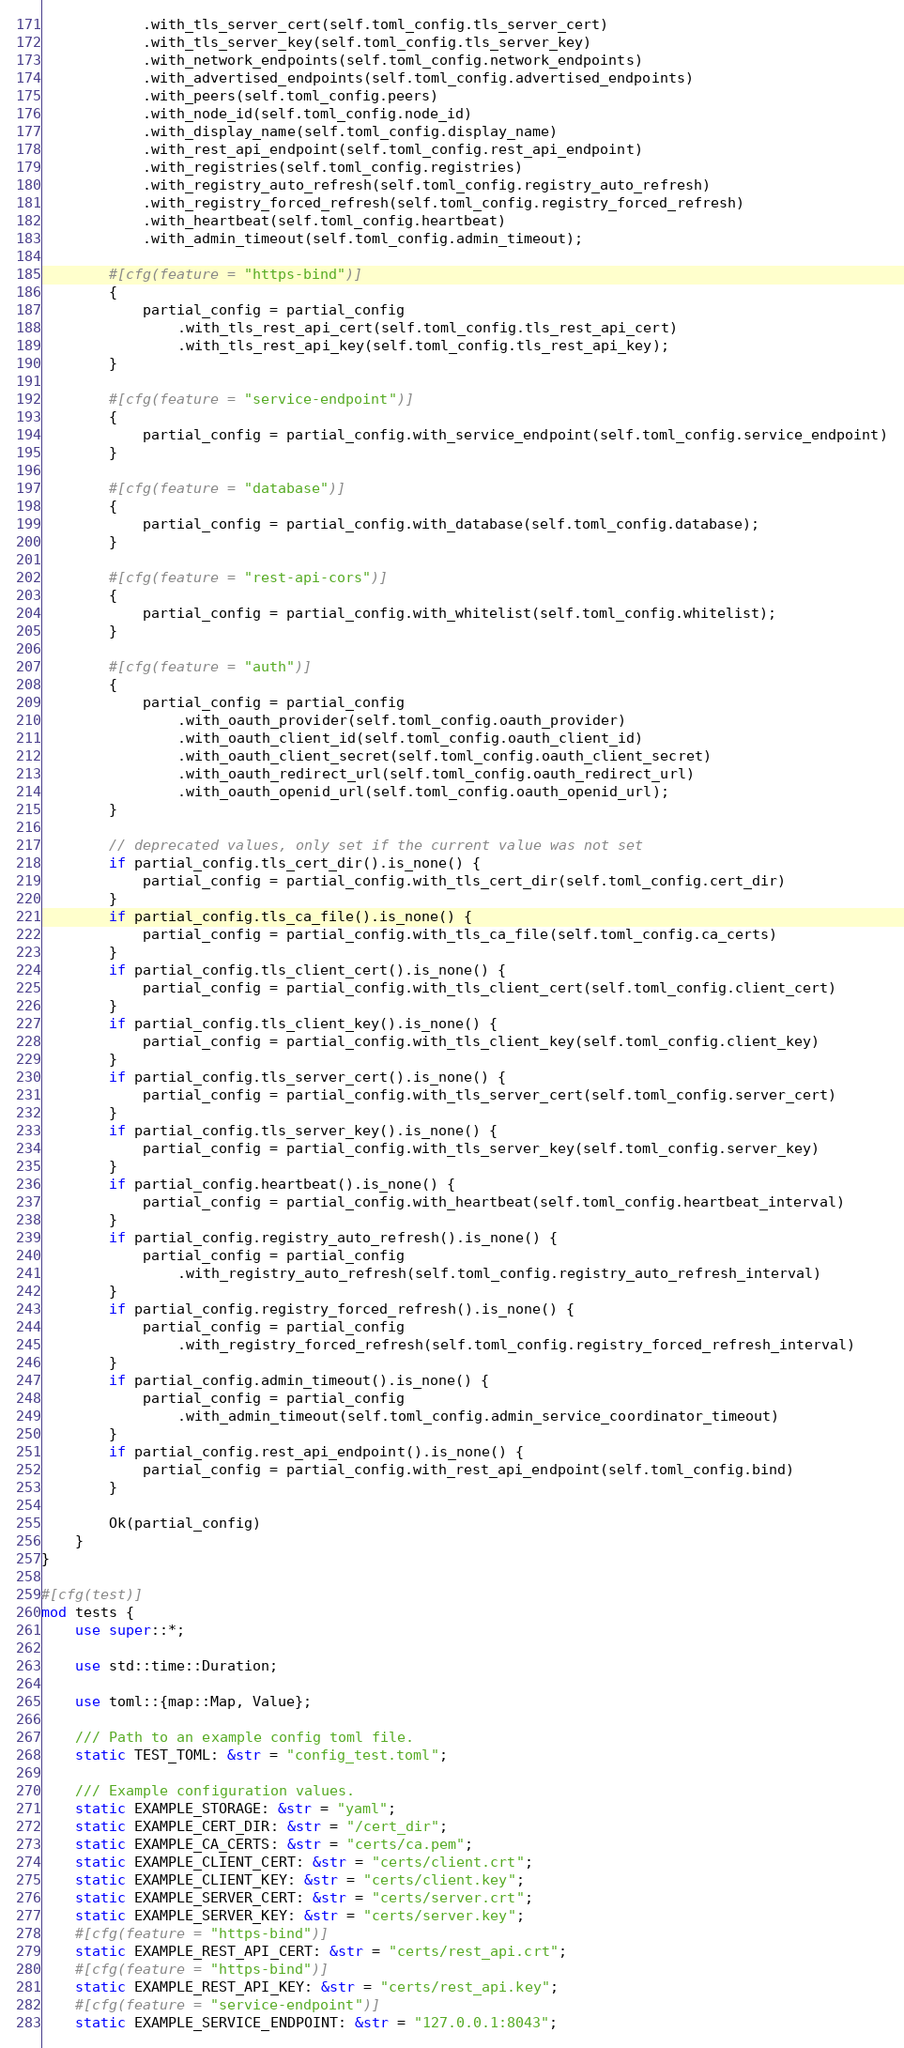<code> <loc_0><loc_0><loc_500><loc_500><_Rust_>            .with_tls_server_cert(self.toml_config.tls_server_cert)
            .with_tls_server_key(self.toml_config.tls_server_key)
            .with_network_endpoints(self.toml_config.network_endpoints)
            .with_advertised_endpoints(self.toml_config.advertised_endpoints)
            .with_peers(self.toml_config.peers)
            .with_node_id(self.toml_config.node_id)
            .with_display_name(self.toml_config.display_name)
            .with_rest_api_endpoint(self.toml_config.rest_api_endpoint)
            .with_registries(self.toml_config.registries)
            .with_registry_auto_refresh(self.toml_config.registry_auto_refresh)
            .with_registry_forced_refresh(self.toml_config.registry_forced_refresh)
            .with_heartbeat(self.toml_config.heartbeat)
            .with_admin_timeout(self.toml_config.admin_timeout);

        #[cfg(feature = "https-bind")]
        {
            partial_config = partial_config
                .with_tls_rest_api_cert(self.toml_config.tls_rest_api_cert)
                .with_tls_rest_api_key(self.toml_config.tls_rest_api_key);
        }

        #[cfg(feature = "service-endpoint")]
        {
            partial_config = partial_config.with_service_endpoint(self.toml_config.service_endpoint)
        }

        #[cfg(feature = "database")]
        {
            partial_config = partial_config.with_database(self.toml_config.database);
        }

        #[cfg(feature = "rest-api-cors")]
        {
            partial_config = partial_config.with_whitelist(self.toml_config.whitelist);
        }

        #[cfg(feature = "auth")]
        {
            partial_config = partial_config
                .with_oauth_provider(self.toml_config.oauth_provider)
                .with_oauth_client_id(self.toml_config.oauth_client_id)
                .with_oauth_client_secret(self.toml_config.oauth_client_secret)
                .with_oauth_redirect_url(self.toml_config.oauth_redirect_url)
                .with_oauth_openid_url(self.toml_config.oauth_openid_url);
        }

        // deprecated values, only set if the current value was not set
        if partial_config.tls_cert_dir().is_none() {
            partial_config = partial_config.with_tls_cert_dir(self.toml_config.cert_dir)
        }
        if partial_config.tls_ca_file().is_none() {
            partial_config = partial_config.with_tls_ca_file(self.toml_config.ca_certs)
        }
        if partial_config.tls_client_cert().is_none() {
            partial_config = partial_config.with_tls_client_cert(self.toml_config.client_cert)
        }
        if partial_config.tls_client_key().is_none() {
            partial_config = partial_config.with_tls_client_key(self.toml_config.client_key)
        }
        if partial_config.tls_server_cert().is_none() {
            partial_config = partial_config.with_tls_server_cert(self.toml_config.server_cert)
        }
        if partial_config.tls_server_key().is_none() {
            partial_config = partial_config.with_tls_server_key(self.toml_config.server_key)
        }
        if partial_config.heartbeat().is_none() {
            partial_config = partial_config.with_heartbeat(self.toml_config.heartbeat_interval)
        }
        if partial_config.registry_auto_refresh().is_none() {
            partial_config = partial_config
                .with_registry_auto_refresh(self.toml_config.registry_auto_refresh_interval)
        }
        if partial_config.registry_forced_refresh().is_none() {
            partial_config = partial_config
                .with_registry_forced_refresh(self.toml_config.registry_forced_refresh_interval)
        }
        if partial_config.admin_timeout().is_none() {
            partial_config = partial_config
                .with_admin_timeout(self.toml_config.admin_service_coordinator_timeout)
        }
        if partial_config.rest_api_endpoint().is_none() {
            partial_config = partial_config.with_rest_api_endpoint(self.toml_config.bind)
        }

        Ok(partial_config)
    }
}

#[cfg(test)]
mod tests {
    use super::*;

    use std::time::Duration;

    use toml::{map::Map, Value};

    /// Path to an example config toml file.
    static TEST_TOML: &str = "config_test.toml";

    /// Example configuration values.
    static EXAMPLE_STORAGE: &str = "yaml";
    static EXAMPLE_CERT_DIR: &str = "/cert_dir";
    static EXAMPLE_CA_CERTS: &str = "certs/ca.pem";
    static EXAMPLE_CLIENT_CERT: &str = "certs/client.crt";
    static EXAMPLE_CLIENT_KEY: &str = "certs/client.key";
    static EXAMPLE_SERVER_CERT: &str = "certs/server.crt";
    static EXAMPLE_SERVER_KEY: &str = "certs/server.key";
    #[cfg(feature = "https-bind")]
    static EXAMPLE_REST_API_CERT: &str = "certs/rest_api.crt";
    #[cfg(feature = "https-bind")]
    static EXAMPLE_REST_API_KEY: &str = "certs/rest_api.key";
    #[cfg(feature = "service-endpoint")]
    static EXAMPLE_SERVICE_ENDPOINT: &str = "127.0.0.1:8043";</code> 